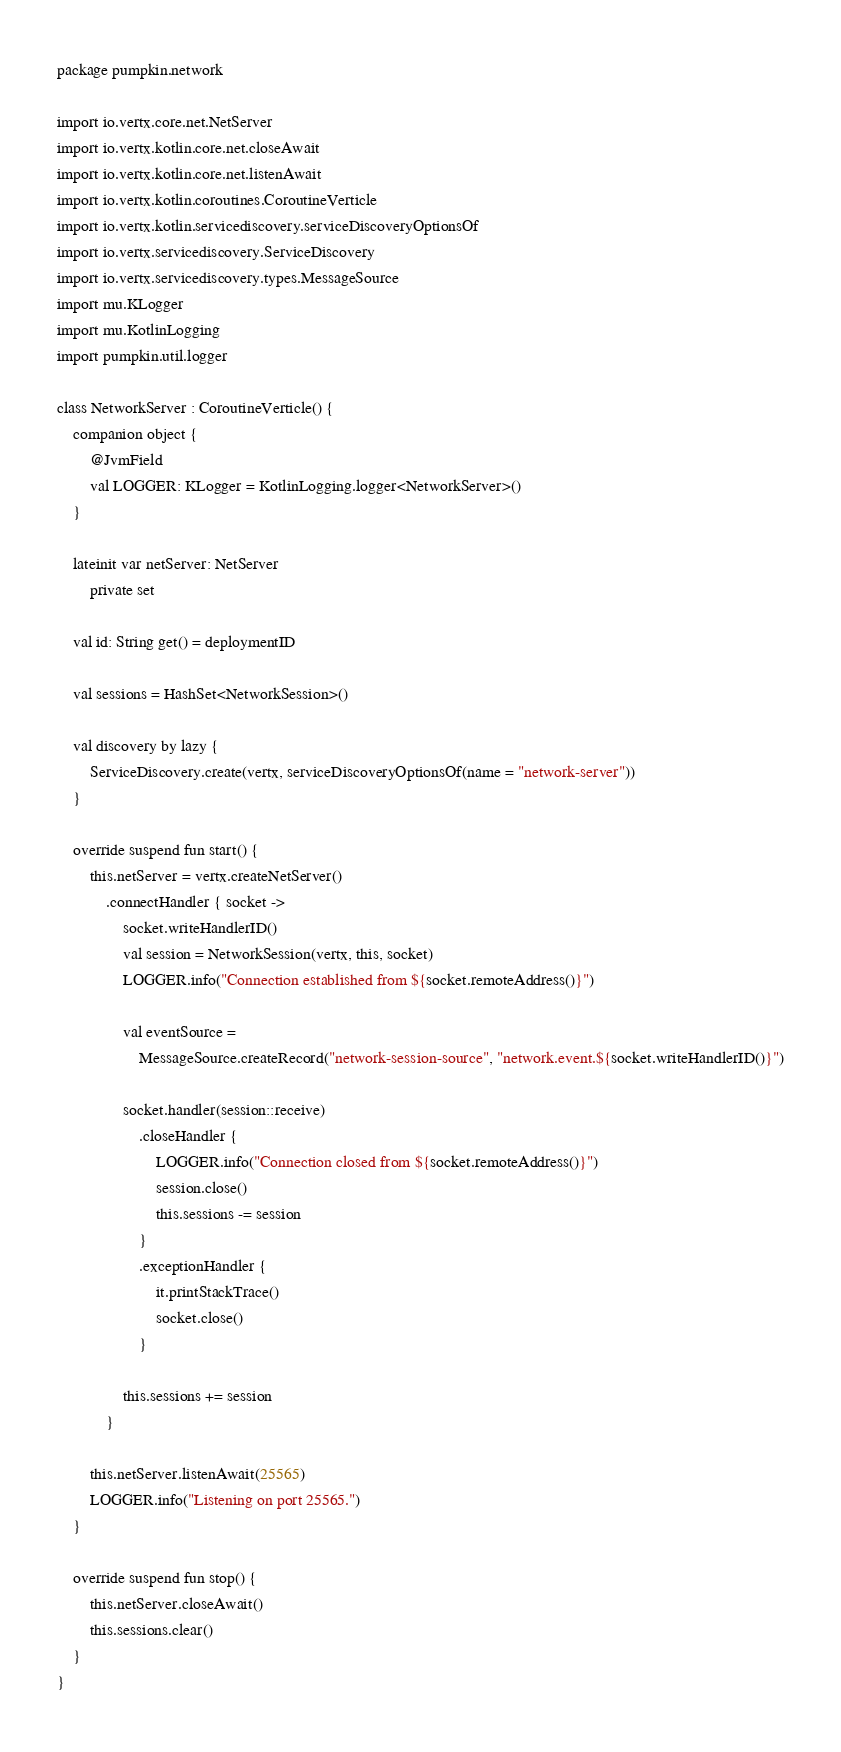<code> <loc_0><loc_0><loc_500><loc_500><_Kotlin_>package pumpkin.network

import io.vertx.core.net.NetServer
import io.vertx.kotlin.core.net.closeAwait
import io.vertx.kotlin.core.net.listenAwait
import io.vertx.kotlin.coroutines.CoroutineVerticle
import io.vertx.kotlin.servicediscovery.serviceDiscoveryOptionsOf
import io.vertx.servicediscovery.ServiceDiscovery
import io.vertx.servicediscovery.types.MessageSource
import mu.KLogger
import mu.KotlinLogging
import pumpkin.util.logger

class NetworkServer : CoroutineVerticle() {
    companion object {
        @JvmField
        val LOGGER: KLogger = KotlinLogging.logger<NetworkServer>()
    }

    lateinit var netServer: NetServer
        private set

    val id: String get() = deploymentID

    val sessions = HashSet<NetworkSession>()

    val discovery by lazy {
        ServiceDiscovery.create(vertx, serviceDiscoveryOptionsOf(name = "network-server"))
    }

    override suspend fun start() {
        this.netServer = vertx.createNetServer()
            .connectHandler { socket ->
                socket.writeHandlerID()
                val session = NetworkSession(vertx, this, socket)
                LOGGER.info("Connection established from ${socket.remoteAddress()}")

                val eventSource =
                    MessageSource.createRecord("network-session-source", "network.event.${socket.writeHandlerID()}")

                socket.handler(session::receive)
                    .closeHandler {
                        LOGGER.info("Connection closed from ${socket.remoteAddress()}")
                        session.close()
                        this.sessions -= session
                    }
                    .exceptionHandler {
                        it.printStackTrace()
                        socket.close()
                    }

                this.sessions += session
            }

        this.netServer.listenAwait(25565)
        LOGGER.info("Listening on port 25565.")
    }

    override suspend fun stop() {
        this.netServer.closeAwait()
        this.sessions.clear()
    }
}</code> 